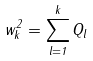<formula> <loc_0><loc_0><loc_500><loc_500>w _ { k } ^ { 2 } = \sum _ { l = 1 } ^ { k } Q _ { l }</formula> 